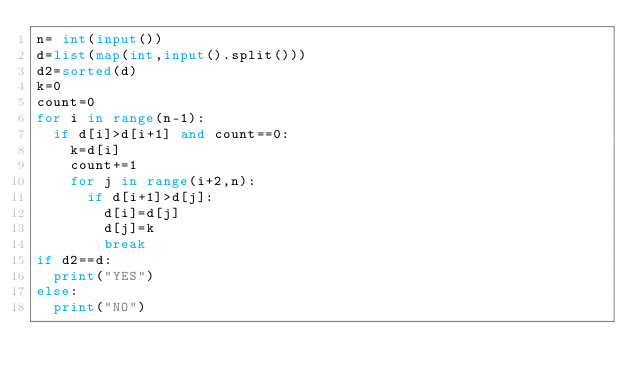<code> <loc_0><loc_0><loc_500><loc_500><_Python_>n= int(input())
d=list(map(int,input().split()))
d2=sorted(d)
k=0
count=0
for i in range(n-1):
  if d[i]>d[i+1] and count==0:
    k=d[i]
    count+=1
    for j in range(i+2,n):
      if d[i+1]>d[j]:
        d[i]=d[j]
        d[j]=k
        break
if d2==d:
  print("YES")
else:
  print("NO")</code> 